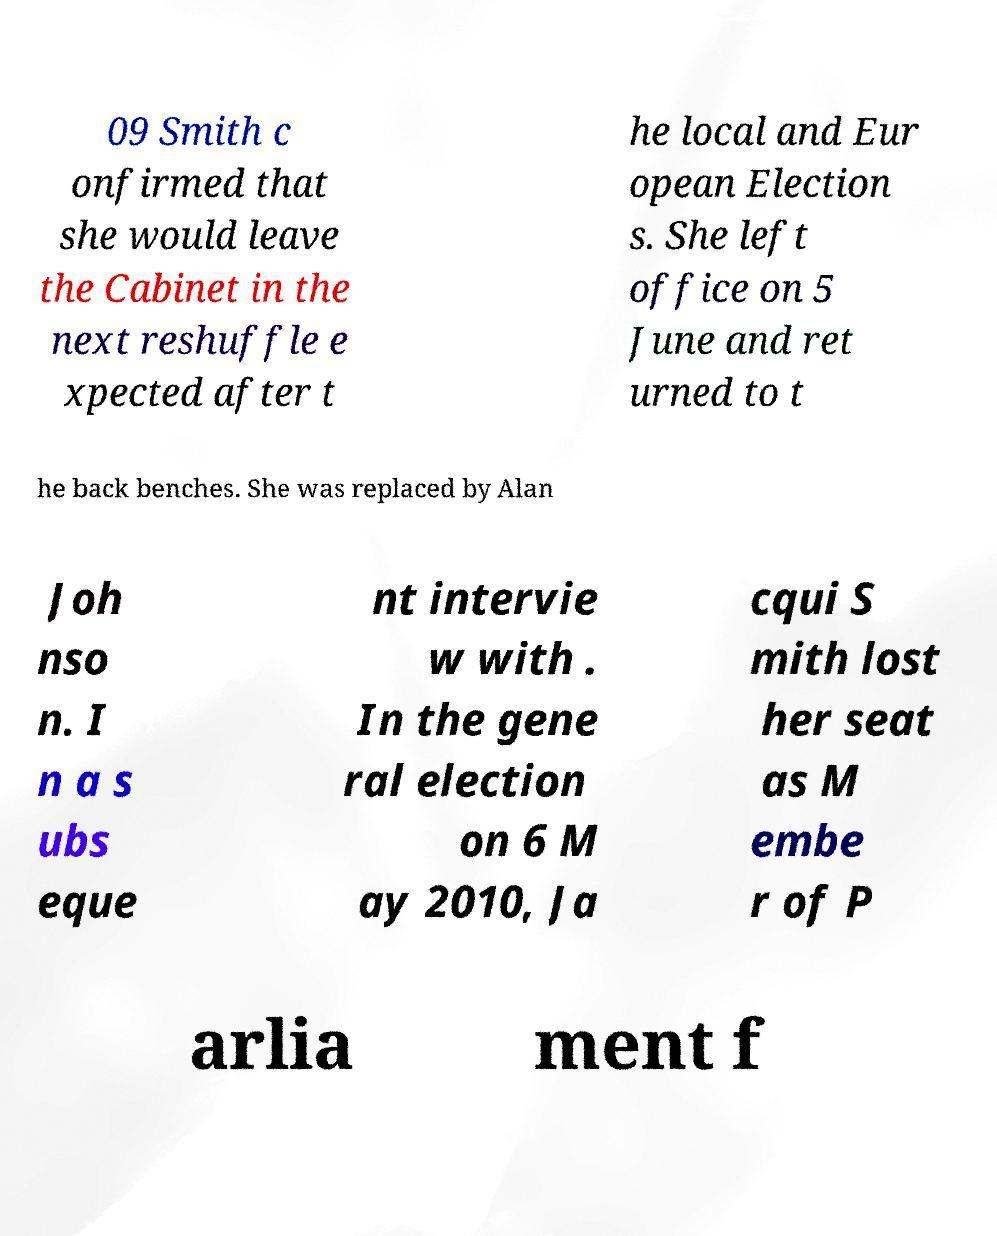Please identify and transcribe the text found in this image. 09 Smith c onfirmed that she would leave the Cabinet in the next reshuffle e xpected after t he local and Eur opean Election s. She left office on 5 June and ret urned to t he back benches. She was replaced by Alan Joh nso n. I n a s ubs eque nt intervie w with . In the gene ral election on 6 M ay 2010, Ja cqui S mith lost her seat as M embe r of P arlia ment f 